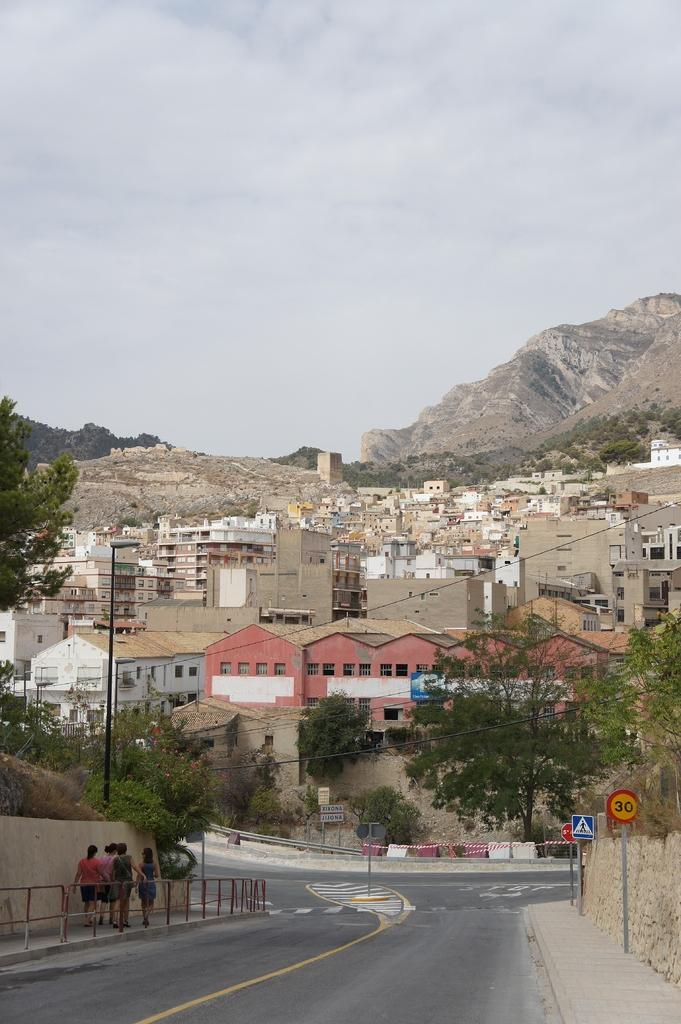What is the main feature of the image? There is a road in the image. Can you describe the people in the image? There are persons visible in the image. What type of structures can be seen in the image? There are poles, boards, a wall, and houses in the image. What natural elements are present in the image? There are trees and a mountain in the image. What is visible in the background of the image? There is sky visible in the background of the image, with clouds present. What type of seed is being planted by the family in the image? There is no family or seed present in the image. 